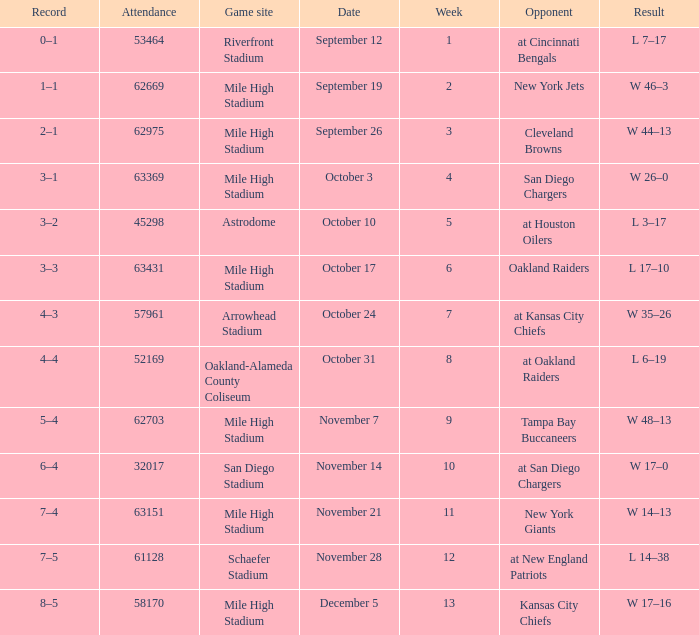What was the week number when the opponent was the New York Jets? 2.0. 